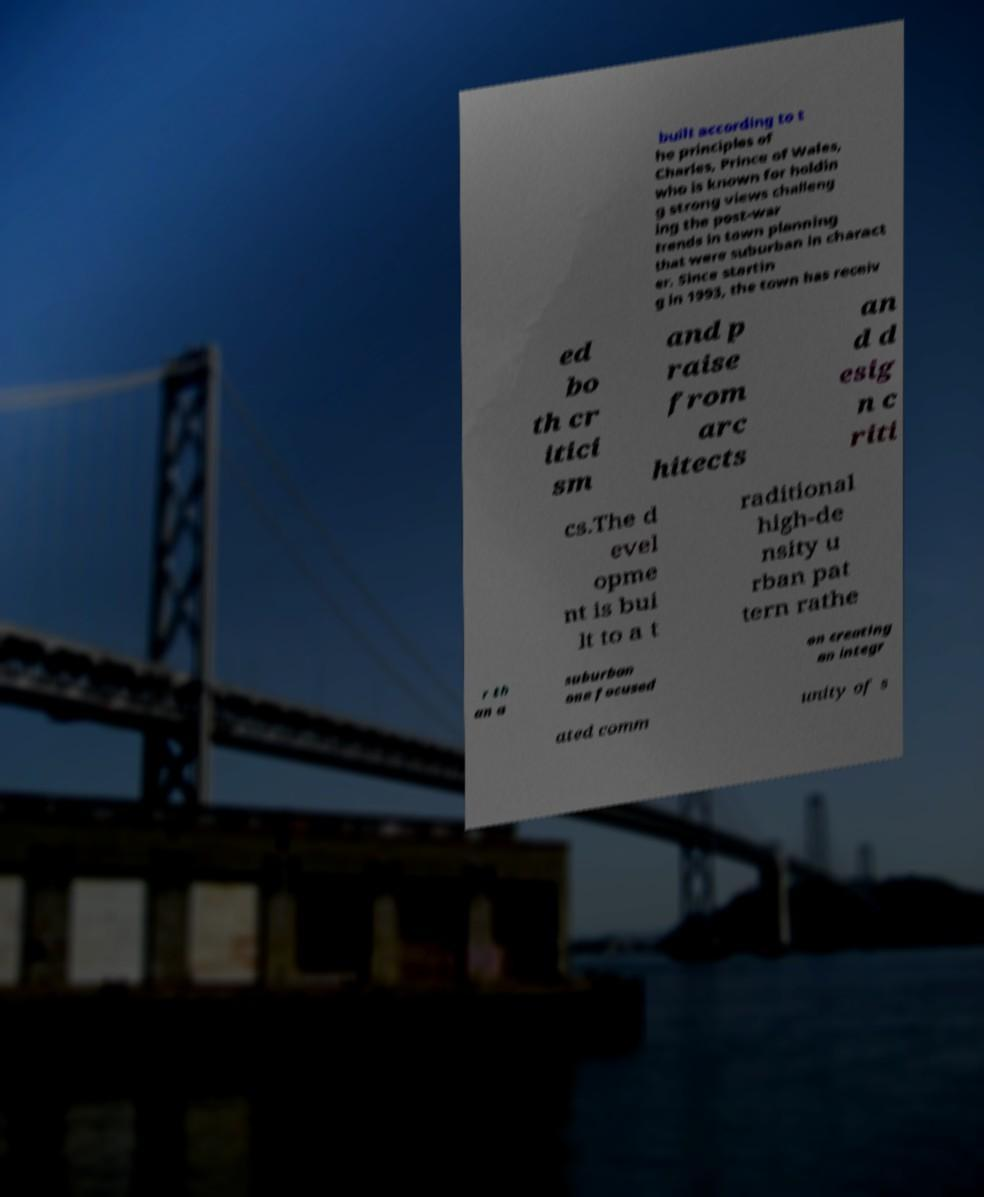For documentation purposes, I need the text within this image transcribed. Could you provide that? built according to t he principles of Charles, Prince of Wales, who is known for holdin g strong views challeng ing the post-war trends in town planning that were suburban in charact er. Since startin g in 1993, the town has receiv ed bo th cr itici sm and p raise from arc hitects an d d esig n c riti cs.The d evel opme nt is bui lt to a t raditional high-de nsity u rban pat tern rathe r th an a suburban one focused on creating an integr ated comm unity of s 